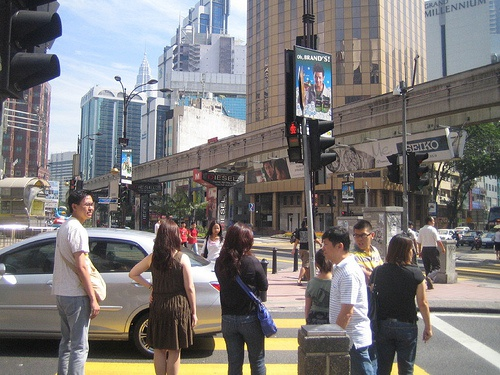Describe the objects in this image and their specific colors. I can see car in black, gray, white, and darkgray tones, people in black, gray, brown, and maroon tones, people in black and gray tones, people in black, gray, darkgray, and white tones, and people in black and gray tones in this image. 